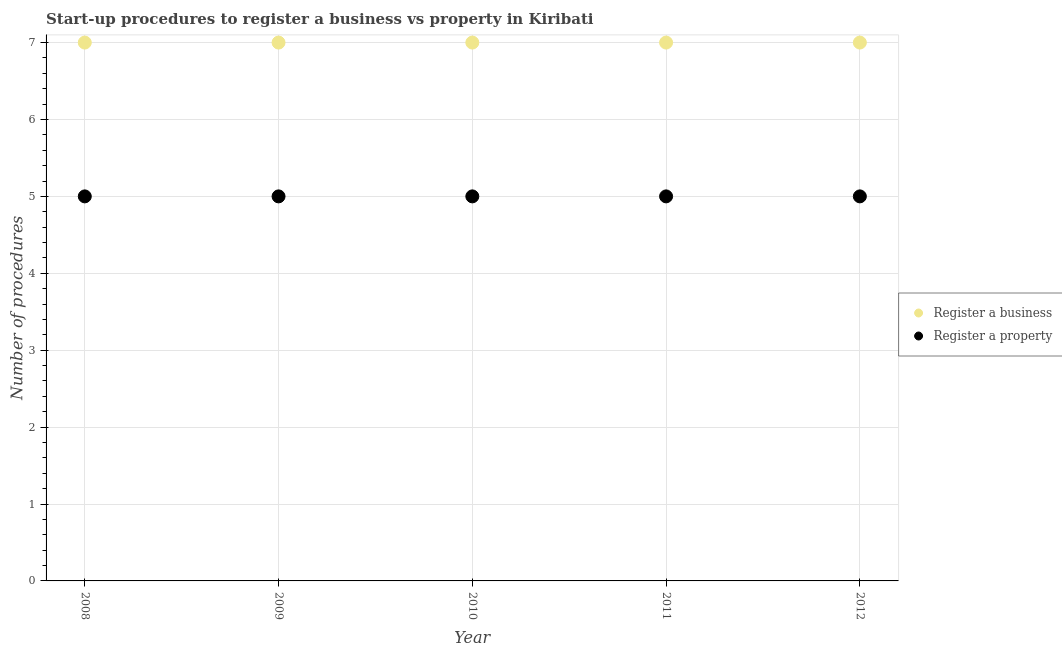How many different coloured dotlines are there?
Provide a succinct answer. 2. What is the number of procedures to register a business in 2012?
Give a very brief answer. 7. Across all years, what is the maximum number of procedures to register a property?
Offer a terse response. 5. Across all years, what is the minimum number of procedures to register a business?
Provide a short and direct response. 7. What is the total number of procedures to register a property in the graph?
Your answer should be very brief. 25. What is the difference between the number of procedures to register a business in 2010 and that in 2012?
Offer a very short reply. 0. What is the difference between the number of procedures to register a property in 2011 and the number of procedures to register a business in 2008?
Your response must be concise. -2. In the year 2008, what is the difference between the number of procedures to register a business and number of procedures to register a property?
Your response must be concise. 2. In how many years, is the number of procedures to register a property greater than 6.6?
Provide a short and direct response. 0. Is the sum of the number of procedures to register a property in 2008 and 2009 greater than the maximum number of procedures to register a business across all years?
Offer a very short reply. Yes. Does the number of procedures to register a business monotonically increase over the years?
Your answer should be very brief. No. Is the number of procedures to register a business strictly greater than the number of procedures to register a property over the years?
Keep it short and to the point. Yes. Is the number of procedures to register a business strictly less than the number of procedures to register a property over the years?
Keep it short and to the point. No. How many years are there in the graph?
Your response must be concise. 5. What is the difference between two consecutive major ticks on the Y-axis?
Your answer should be very brief. 1. Does the graph contain grids?
Offer a terse response. Yes. Where does the legend appear in the graph?
Your answer should be very brief. Center right. What is the title of the graph?
Give a very brief answer. Start-up procedures to register a business vs property in Kiribati. What is the label or title of the X-axis?
Ensure brevity in your answer.  Year. What is the label or title of the Y-axis?
Provide a short and direct response. Number of procedures. What is the Number of procedures of Register a business in 2009?
Provide a short and direct response. 7. What is the Number of procedures of Register a business in 2010?
Offer a very short reply. 7. What is the Number of procedures of Register a property in 2011?
Provide a short and direct response. 5. What is the Number of procedures in Register a property in 2012?
Ensure brevity in your answer.  5. Across all years, what is the minimum Number of procedures in Register a property?
Your answer should be very brief. 5. What is the total Number of procedures in Register a business in the graph?
Keep it short and to the point. 35. What is the total Number of procedures in Register a property in the graph?
Your answer should be very brief. 25. What is the difference between the Number of procedures of Register a business in 2008 and that in 2009?
Your answer should be very brief. 0. What is the difference between the Number of procedures in Register a business in 2008 and that in 2010?
Provide a short and direct response. 0. What is the difference between the Number of procedures of Register a property in 2008 and that in 2010?
Provide a short and direct response. 0. What is the difference between the Number of procedures in Register a business in 2008 and that in 2011?
Offer a very short reply. 0. What is the difference between the Number of procedures of Register a property in 2008 and that in 2011?
Offer a very short reply. 0. What is the difference between the Number of procedures in Register a property in 2009 and that in 2010?
Ensure brevity in your answer.  0. What is the difference between the Number of procedures in Register a business in 2010 and that in 2011?
Ensure brevity in your answer.  0. What is the difference between the Number of procedures in Register a property in 2010 and that in 2011?
Your response must be concise. 0. What is the difference between the Number of procedures in Register a business in 2011 and that in 2012?
Your answer should be very brief. 0. What is the difference between the Number of procedures in Register a business in 2008 and the Number of procedures in Register a property in 2010?
Your answer should be compact. 2. What is the difference between the Number of procedures of Register a business in 2008 and the Number of procedures of Register a property in 2011?
Your response must be concise. 2. What is the difference between the Number of procedures in Register a business in 2008 and the Number of procedures in Register a property in 2012?
Provide a succinct answer. 2. What is the difference between the Number of procedures in Register a business in 2009 and the Number of procedures in Register a property in 2011?
Offer a very short reply. 2. What is the difference between the Number of procedures in Register a business in 2009 and the Number of procedures in Register a property in 2012?
Offer a very short reply. 2. What is the average Number of procedures of Register a business per year?
Your answer should be compact. 7. In the year 2010, what is the difference between the Number of procedures of Register a business and Number of procedures of Register a property?
Your answer should be very brief. 2. What is the ratio of the Number of procedures of Register a property in 2008 to that in 2009?
Offer a terse response. 1. What is the ratio of the Number of procedures in Register a property in 2008 to that in 2010?
Offer a very short reply. 1. What is the ratio of the Number of procedures in Register a business in 2008 to that in 2012?
Your response must be concise. 1. What is the ratio of the Number of procedures of Register a property in 2008 to that in 2012?
Offer a terse response. 1. What is the ratio of the Number of procedures of Register a business in 2009 to that in 2010?
Ensure brevity in your answer.  1. What is the ratio of the Number of procedures of Register a business in 2009 to that in 2011?
Provide a short and direct response. 1. What is the ratio of the Number of procedures in Register a property in 2009 to that in 2011?
Provide a short and direct response. 1. What is the ratio of the Number of procedures in Register a business in 2009 to that in 2012?
Give a very brief answer. 1. What is the ratio of the Number of procedures of Register a business in 2010 to that in 2011?
Ensure brevity in your answer.  1. What is the ratio of the Number of procedures in Register a property in 2010 to that in 2011?
Your response must be concise. 1. What is the ratio of the Number of procedures in Register a property in 2011 to that in 2012?
Ensure brevity in your answer.  1. What is the difference between the highest and the lowest Number of procedures of Register a business?
Offer a terse response. 0. What is the difference between the highest and the lowest Number of procedures in Register a property?
Provide a short and direct response. 0. 